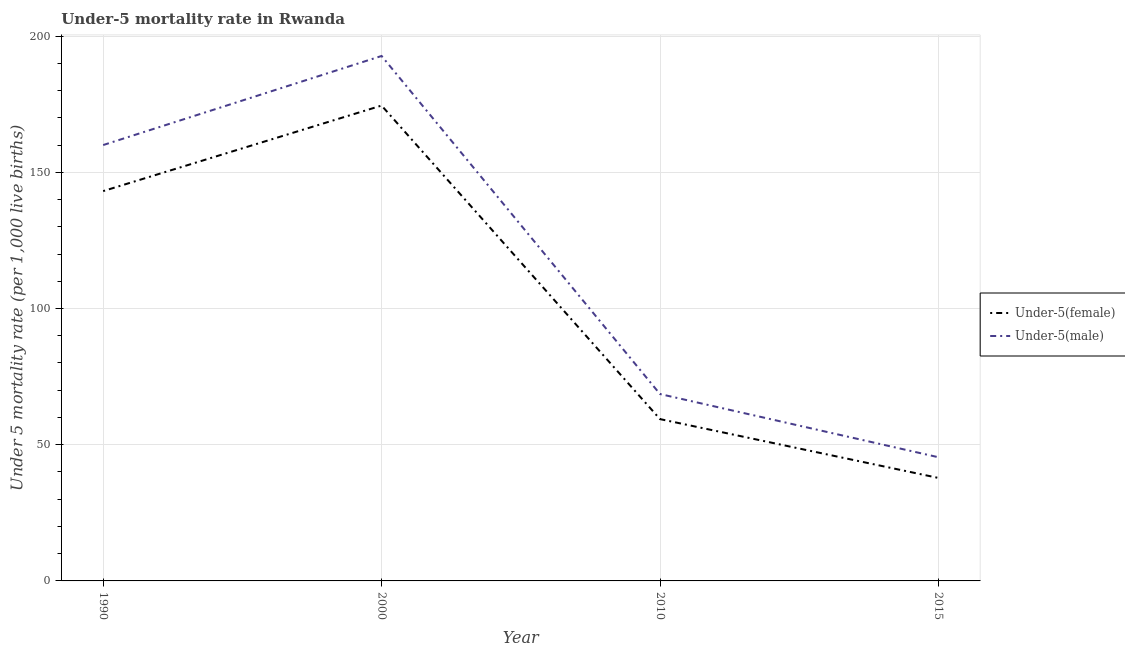How many different coloured lines are there?
Your response must be concise. 2. What is the under-5 male mortality rate in 2010?
Make the answer very short. 68.6. Across all years, what is the maximum under-5 female mortality rate?
Your response must be concise. 174.5. Across all years, what is the minimum under-5 female mortality rate?
Make the answer very short. 37.8. In which year was the under-5 female mortality rate minimum?
Give a very brief answer. 2015. What is the total under-5 male mortality rate in the graph?
Your answer should be compact. 466.7. What is the difference between the under-5 male mortality rate in 1990 and that in 2000?
Offer a very short reply. -32.7. What is the difference between the under-5 male mortality rate in 2015 and the under-5 female mortality rate in 2000?
Provide a succinct answer. -129.1. What is the average under-5 female mortality rate per year?
Provide a succinct answer. 103.7. In the year 2015, what is the difference between the under-5 male mortality rate and under-5 female mortality rate?
Your response must be concise. 7.6. In how many years, is the under-5 female mortality rate greater than 10?
Your answer should be compact. 4. What is the ratio of the under-5 male mortality rate in 2000 to that in 2015?
Provide a short and direct response. 4.24. Is the under-5 female mortality rate in 1990 less than that in 2015?
Ensure brevity in your answer.  No. Is the difference between the under-5 male mortality rate in 2010 and 2015 greater than the difference between the under-5 female mortality rate in 2010 and 2015?
Make the answer very short. Yes. What is the difference between the highest and the second highest under-5 female mortality rate?
Provide a short and direct response. 31.4. What is the difference between the highest and the lowest under-5 male mortality rate?
Your answer should be compact. 147.3. In how many years, is the under-5 male mortality rate greater than the average under-5 male mortality rate taken over all years?
Provide a succinct answer. 2. Does the under-5 male mortality rate monotonically increase over the years?
Keep it short and to the point. No. Is the under-5 male mortality rate strictly greater than the under-5 female mortality rate over the years?
Give a very brief answer. Yes. How many lines are there?
Ensure brevity in your answer.  2. How many years are there in the graph?
Keep it short and to the point. 4. Are the values on the major ticks of Y-axis written in scientific E-notation?
Your answer should be compact. No. Does the graph contain any zero values?
Provide a short and direct response. No. Does the graph contain grids?
Provide a succinct answer. Yes. How are the legend labels stacked?
Give a very brief answer. Vertical. What is the title of the graph?
Give a very brief answer. Under-5 mortality rate in Rwanda. What is the label or title of the X-axis?
Ensure brevity in your answer.  Year. What is the label or title of the Y-axis?
Provide a succinct answer. Under 5 mortality rate (per 1,0 live births). What is the Under 5 mortality rate (per 1,000 live births) in Under-5(female) in 1990?
Provide a short and direct response. 143.1. What is the Under 5 mortality rate (per 1,000 live births) in Under-5(male) in 1990?
Your response must be concise. 160. What is the Under 5 mortality rate (per 1,000 live births) of Under-5(female) in 2000?
Give a very brief answer. 174.5. What is the Under 5 mortality rate (per 1,000 live births) of Under-5(male) in 2000?
Offer a terse response. 192.7. What is the Under 5 mortality rate (per 1,000 live births) in Under-5(female) in 2010?
Your answer should be compact. 59.4. What is the Under 5 mortality rate (per 1,000 live births) of Under-5(male) in 2010?
Ensure brevity in your answer.  68.6. What is the Under 5 mortality rate (per 1,000 live births) in Under-5(female) in 2015?
Your answer should be compact. 37.8. What is the Under 5 mortality rate (per 1,000 live births) of Under-5(male) in 2015?
Offer a very short reply. 45.4. Across all years, what is the maximum Under 5 mortality rate (per 1,000 live births) in Under-5(female)?
Keep it short and to the point. 174.5. Across all years, what is the maximum Under 5 mortality rate (per 1,000 live births) of Under-5(male)?
Ensure brevity in your answer.  192.7. Across all years, what is the minimum Under 5 mortality rate (per 1,000 live births) in Under-5(female)?
Provide a short and direct response. 37.8. Across all years, what is the minimum Under 5 mortality rate (per 1,000 live births) of Under-5(male)?
Keep it short and to the point. 45.4. What is the total Under 5 mortality rate (per 1,000 live births) in Under-5(female) in the graph?
Keep it short and to the point. 414.8. What is the total Under 5 mortality rate (per 1,000 live births) of Under-5(male) in the graph?
Your answer should be compact. 466.7. What is the difference between the Under 5 mortality rate (per 1,000 live births) in Under-5(female) in 1990 and that in 2000?
Make the answer very short. -31.4. What is the difference between the Under 5 mortality rate (per 1,000 live births) in Under-5(male) in 1990 and that in 2000?
Your answer should be very brief. -32.7. What is the difference between the Under 5 mortality rate (per 1,000 live births) of Under-5(female) in 1990 and that in 2010?
Provide a short and direct response. 83.7. What is the difference between the Under 5 mortality rate (per 1,000 live births) of Under-5(male) in 1990 and that in 2010?
Offer a very short reply. 91.4. What is the difference between the Under 5 mortality rate (per 1,000 live births) of Under-5(female) in 1990 and that in 2015?
Offer a terse response. 105.3. What is the difference between the Under 5 mortality rate (per 1,000 live births) of Under-5(male) in 1990 and that in 2015?
Offer a terse response. 114.6. What is the difference between the Under 5 mortality rate (per 1,000 live births) in Under-5(female) in 2000 and that in 2010?
Offer a very short reply. 115.1. What is the difference between the Under 5 mortality rate (per 1,000 live births) in Under-5(male) in 2000 and that in 2010?
Ensure brevity in your answer.  124.1. What is the difference between the Under 5 mortality rate (per 1,000 live births) in Under-5(female) in 2000 and that in 2015?
Give a very brief answer. 136.7. What is the difference between the Under 5 mortality rate (per 1,000 live births) of Under-5(male) in 2000 and that in 2015?
Offer a terse response. 147.3. What is the difference between the Under 5 mortality rate (per 1,000 live births) of Under-5(female) in 2010 and that in 2015?
Provide a succinct answer. 21.6. What is the difference between the Under 5 mortality rate (per 1,000 live births) in Under-5(male) in 2010 and that in 2015?
Provide a short and direct response. 23.2. What is the difference between the Under 5 mortality rate (per 1,000 live births) in Under-5(female) in 1990 and the Under 5 mortality rate (per 1,000 live births) in Under-5(male) in 2000?
Keep it short and to the point. -49.6. What is the difference between the Under 5 mortality rate (per 1,000 live births) in Under-5(female) in 1990 and the Under 5 mortality rate (per 1,000 live births) in Under-5(male) in 2010?
Provide a succinct answer. 74.5. What is the difference between the Under 5 mortality rate (per 1,000 live births) in Under-5(female) in 1990 and the Under 5 mortality rate (per 1,000 live births) in Under-5(male) in 2015?
Provide a short and direct response. 97.7. What is the difference between the Under 5 mortality rate (per 1,000 live births) in Under-5(female) in 2000 and the Under 5 mortality rate (per 1,000 live births) in Under-5(male) in 2010?
Provide a succinct answer. 105.9. What is the difference between the Under 5 mortality rate (per 1,000 live births) in Under-5(female) in 2000 and the Under 5 mortality rate (per 1,000 live births) in Under-5(male) in 2015?
Your answer should be very brief. 129.1. What is the difference between the Under 5 mortality rate (per 1,000 live births) of Under-5(female) in 2010 and the Under 5 mortality rate (per 1,000 live births) of Under-5(male) in 2015?
Your answer should be very brief. 14. What is the average Under 5 mortality rate (per 1,000 live births) of Under-5(female) per year?
Your response must be concise. 103.7. What is the average Under 5 mortality rate (per 1,000 live births) in Under-5(male) per year?
Ensure brevity in your answer.  116.67. In the year 1990, what is the difference between the Under 5 mortality rate (per 1,000 live births) in Under-5(female) and Under 5 mortality rate (per 1,000 live births) in Under-5(male)?
Offer a very short reply. -16.9. In the year 2000, what is the difference between the Under 5 mortality rate (per 1,000 live births) in Under-5(female) and Under 5 mortality rate (per 1,000 live births) in Under-5(male)?
Keep it short and to the point. -18.2. What is the ratio of the Under 5 mortality rate (per 1,000 live births) in Under-5(female) in 1990 to that in 2000?
Provide a short and direct response. 0.82. What is the ratio of the Under 5 mortality rate (per 1,000 live births) in Under-5(male) in 1990 to that in 2000?
Keep it short and to the point. 0.83. What is the ratio of the Under 5 mortality rate (per 1,000 live births) in Under-5(female) in 1990 to that in 2010?
Offer a very short reply. 2.41. What is the ratio of the Under 5 mortality rate (per 1,000 live births) in Under-5(male) in 1990 to that in 2010?
Give a very brief answer. 2.33. What is the ratio of the Under 5 mortality rate (per 1,000 live births) in Under-5(female) in 1990 to that in 2015?
Give a very brief answer. 3.79. What is the ratio of the Under 5 mortality rate (per 1,000 live births) in Under-5(male) in 1990 to that in 2015?
Offer a very short reply. 3.52. What is the ratio of the Under 5 mortality rate (per 1,000 live births) of Under-5(female) in 2000 to that in 2010?
Keep it short and to the point. 2.94. What is the ratio of the Under 5 mortality rate (per 1,000 live births) in Under-5(male) in 2000 to that in 2010?
Make the answer very short. 2.81. What is the ratio of the Under 5 mortality rate (per 1,000 live births) in Under-5(female) in 2000 to that in 2015?
Your response must be concise. 4.62. What is the ratio of the Under 5 mortality rate (per 1,000 live births) in Under-5(male) in 2000 to that in 2015?
Make the answer very short. 4.24. What is the ratio of the Under 5 mortality rate (per 1,000 live births) of Under-5(female) in 2010 to that in 2015?
Offer a terse response. 1.57. What is the ratio of the Under 5 mortality rate (per 1,000 live births) in Under-5(male) in 2010 to that in 2015?
Offer a very short reply. 1.51. What is the difference between the highest and the second highest Under 5 mortality rate (per 1,000 live births) in Under-5(female)?
Offer a terse response. 31.4. What is the difference between the highest and the second highest Under 5 mortality rate (per 1,000 live births) of Under-5(male)?
Your answer should be compact. 32.7. What is the difference between the highest and the lowest Under 5 mortality rate (per 1,000 live births) of Under-5(female)?
Make the answer very short. 136.7. What is the difference between the highest and the lowest Under 5 mortality rate (per 1,000 live births) in Under-5(male)?
Your response must be concise. 147.3. 